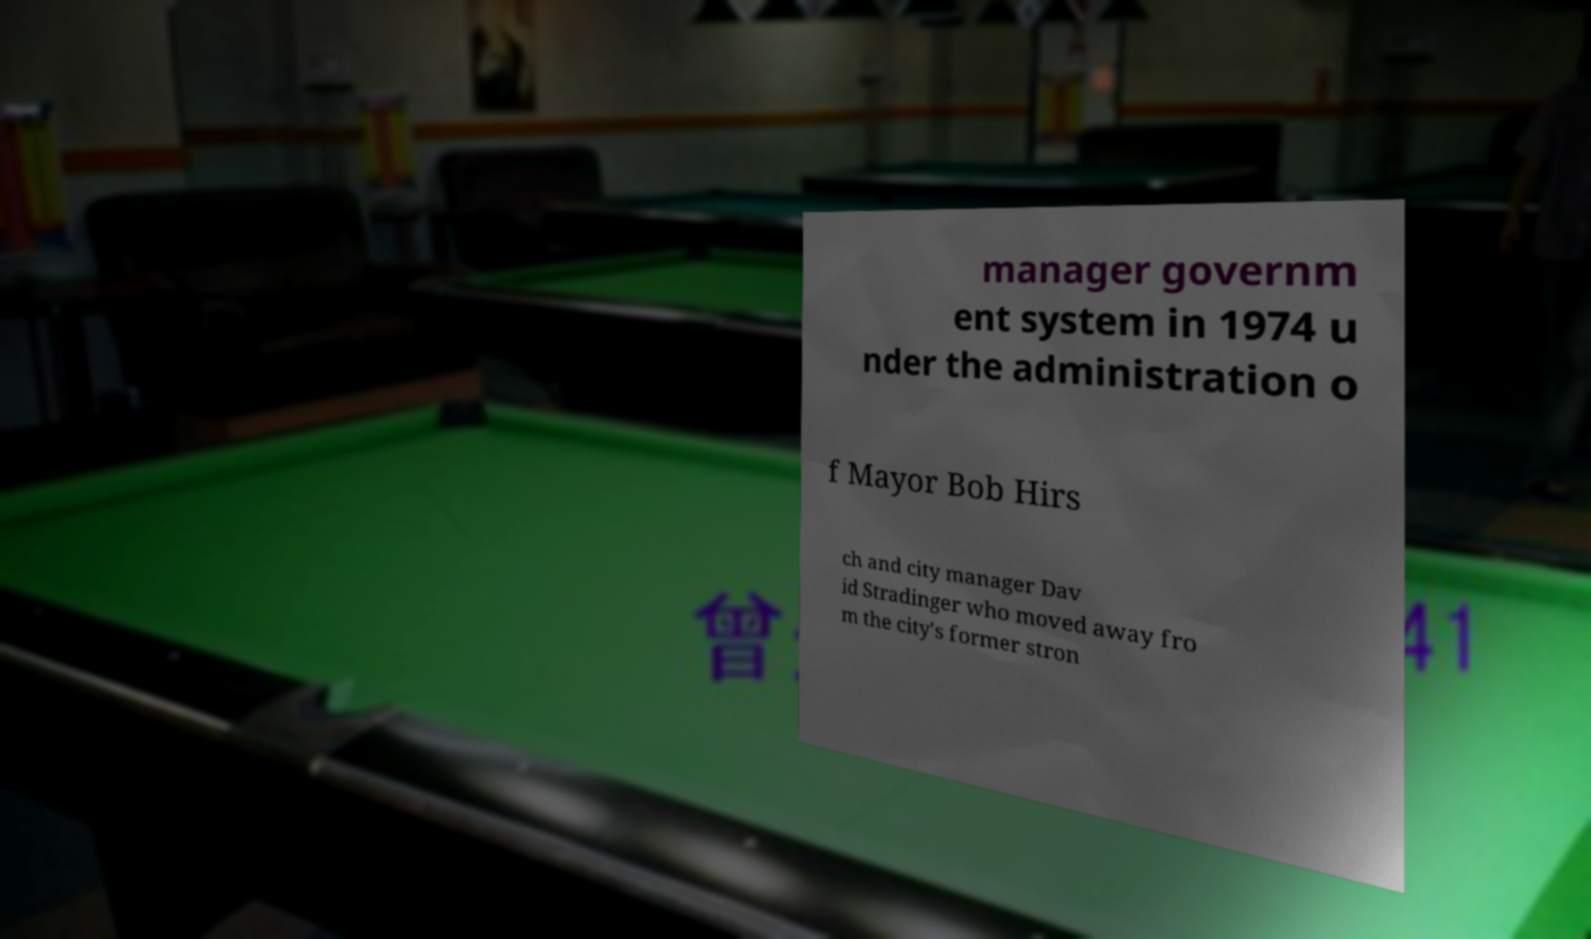I need the written content from this picture converted into text. Can you do that? manager governm ent system in 1974 u nder the administration o f Mayor Bob Hirs ch and city manager Dav id Stradinger who moved away fro m the city's former stron 